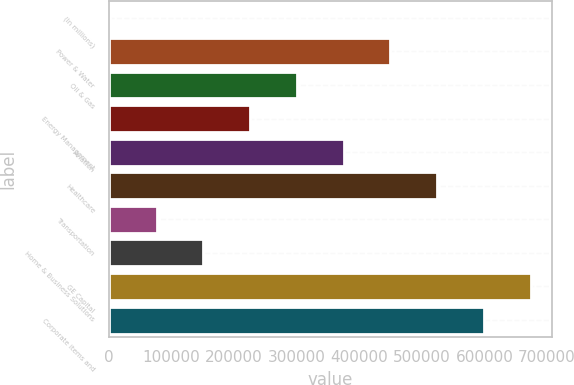Convert chart. <chart><loc_0><loc_0><loc_500><loc_500><bar_chart><fcel>(In millions)<fcel>Power & Water<fcel>Oil & Gas<fcel>Energy Management<fcel>Aviation<fcel>Healthcare<fcel>Transportation<fcel>Home & Business Solutions<fcel>GE Capital<fcel>Corporate items and<nl><fcel>2010<fcel>449899<fcel>300602<fcel>225954<fcel>375250<fcel>524547<fcel>76658.1<fcel>151306<fcel>673843<fcel>599195<nl></chart> 